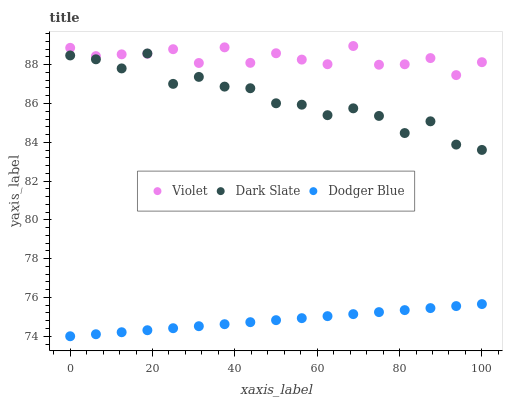Does Dodger Blue have the minimum area under the curve?
Answer yes or no. Yes. Does Violet have the maximum area under the curve?
Answer yes or no. Yes. Does Violet have the minimum area under the curve?
Answer yes or no. No. Does Dodger Blue have the maximum area under the curve?
Answer yes or no. No. Is Dodger Blue the smoothest?
Answer yes or no. Yes. Is Dark Slate the roughest?
Answer yes or no. Yes. Is Violet the smoothest?
Answer yes or no. No. Is Violet the roughest?
Answer yes or no. No. Does Dodger Blue have the lowest value?
Answer yes or no. Yes. Does Violet have the lowest value?
Answer yes or no. No. Does Violet have the highest value?
Answer yes or no. Yes. Does Dodger Blue have the highest value?
Answer yes or no. No. Is Dodger Blue less than Violet?
Answer yes or no. Yes. Is Violet greater than Dodger Blue?
Answer yes or no. Yes. Does Violet intersect Dark Slate?
Answer yes or no. Yes. Is Violet less than Dark Slate?
Answer yes or no. No. Is Violet greater than Dark Slate?
Answer yes or no. No. Does Dodger Blue intersect Violet?
Answer yes or no. No. 